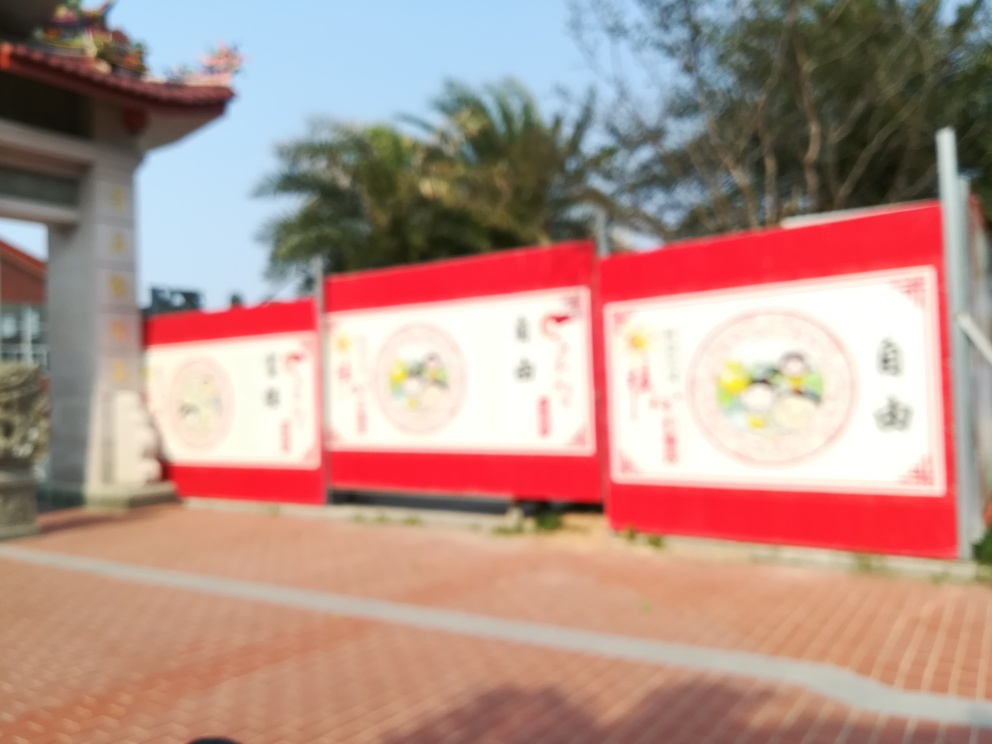Can you describe the atmosphere or vibe that the blurry image conveys? The blurred effect gives the image a dreamy and ethereal quality. It's as if the details are just out of reach, which can stir the viewer's curiosity and invite them to imagine what the clear image might reveal. 